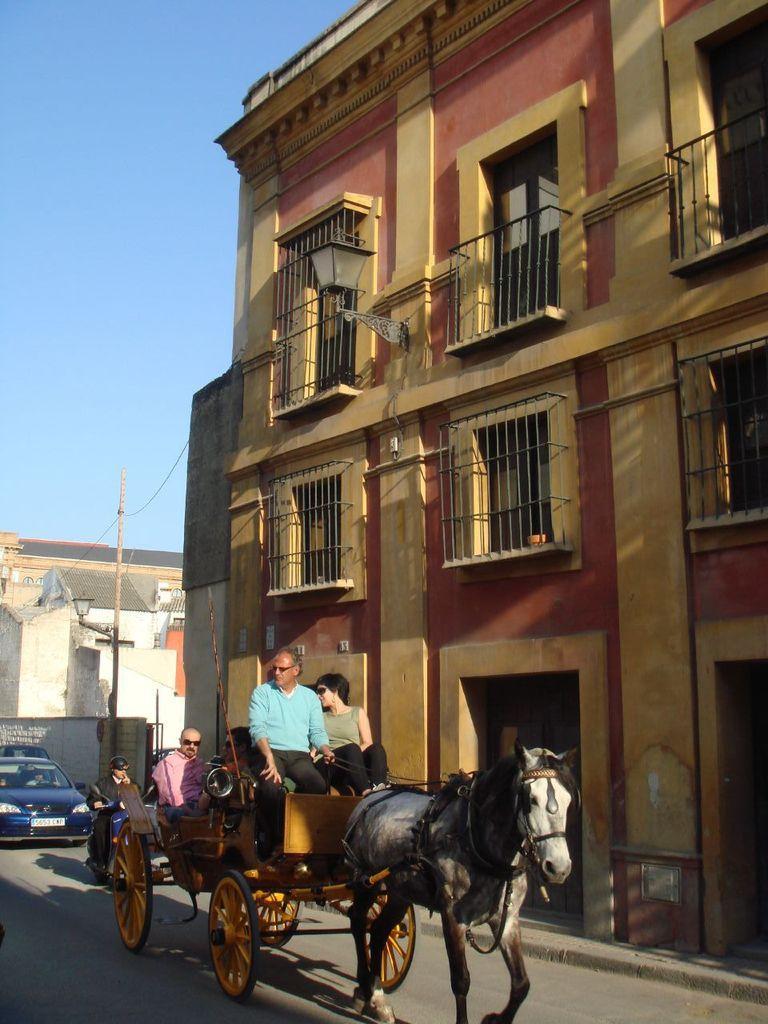Could you give a brief overview of what you see in this image? In this image in the front there are persons sitting on the horse car. In the background there are vehicles and there are buildings. 